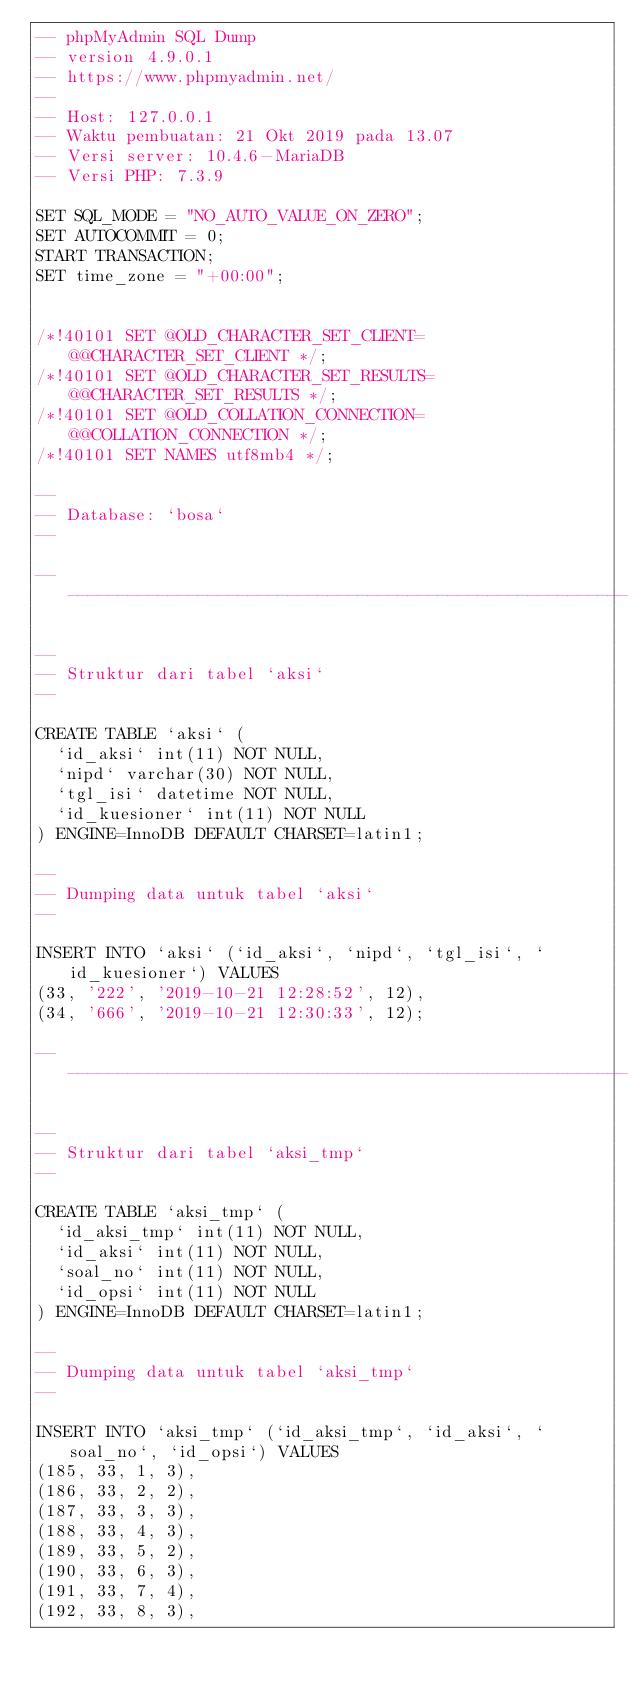<code> <loc_0><loc_0><loc_500><loc_500><_SQL_>-- phpMyAdmin SQL Dump
-- version 4.9.0.1
-- https://www.phpmyadmin.net/
--
-- Host: 127.0.0.1
-- Waktu pembuatan: 21 Okt 2019 pada 13.07
-- Versi server: 10.4.6-MariaDB
-- Versi PHP: 7.3.9

SET SQL_MODE = "NO_AUTO_VALUE_ON_ZERO";
SET AUTOCOMMIT = 0;
START TRANSACTION;
SET time_zone = "+00:00";


/*!40101 SET @OLD_CHARACTER_SET_CLIENT=@@CHARACTER_SET_CLIENT */;
/*!40101 SET @OLD_CHARACTER_SET_RESULTS=@@CHARACTER_SET_RESULTS */;
/*!40101 SET @OLD_COLLATION_CONNECTION=@@COLLATION_CONNECTION */;
/*!40101 SET NAMES utf8mb4 */;

--
-- Database: `bosa`
--

-- --------------------------------------------------------

--
-- Struktur dari tabel `aksi`
--

CREATE TABLE `aksi` (
  `id_aksi` int(11) NOT NULL,
  `nipd` varchar(30) NOT NULL,
  `tgl_isi` datetime NOT NULL,
  `id_kuesioner` int(11) NOT NULL
) ENGINE=InnoDB DEFAULT CHARSET=latin1;

--
-- Dumping data untuk tabel `aksi`
--

INSERT INTO `aksi` (`id_aksi`, `nipd`, `tgl_isi`, `id_kuesioner`) VALUES
(33, '222', '2019-10-21 12:28:52', 12),
(34, '666', '2019-10-21 12:30:33', 12);

-- --------------------------------------------------------

--
-- Struktur dari tabel `aksi_tmp`
--

CREATE TABLE `aksi_tmp` (
  `id_aksi_tmp` int(11) NOT NULL,
  `id_aksi` int(11) NOT NULL,
  `soal_no` int(11) NOT NULL,
  `id_opsi` int(11) NOT NULL
) ENGINE=InnoDB DEFAULT CHARSET=latin1;

--
-- Dumping data untuk tabel `aksi_tmp`
--

INSERT INTO `aksi_tmp` (`id_aksi_tmp`, `id_aksi`, `soal_no`, `id_opsi`) VALUES
(185, 33, 1, 3),
(186, 33, 2, 2),
(187, 33, 3, 3),
(188, 33, 4, 3),
(189, 33, 5, 2),
(190, 33, 6, 3),
(191, 33, 7, 4),
(192, 33, 8, 3),</code> 